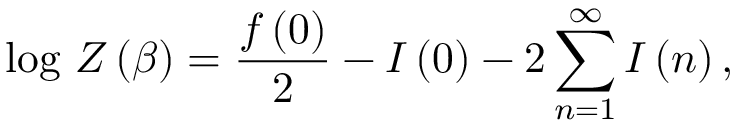Convert formula to latex. <formula><loc_0><loc_0><loc_500><loc_500>\log \, Z \left ( \beta \right ) = \frac { f \left ( 0 \right ) } { 2 } - I \left ( 0 \right ) - 2 \sum _ { n = 1 } ^ { \infty } I \left ( n \right ) ,</formula> 